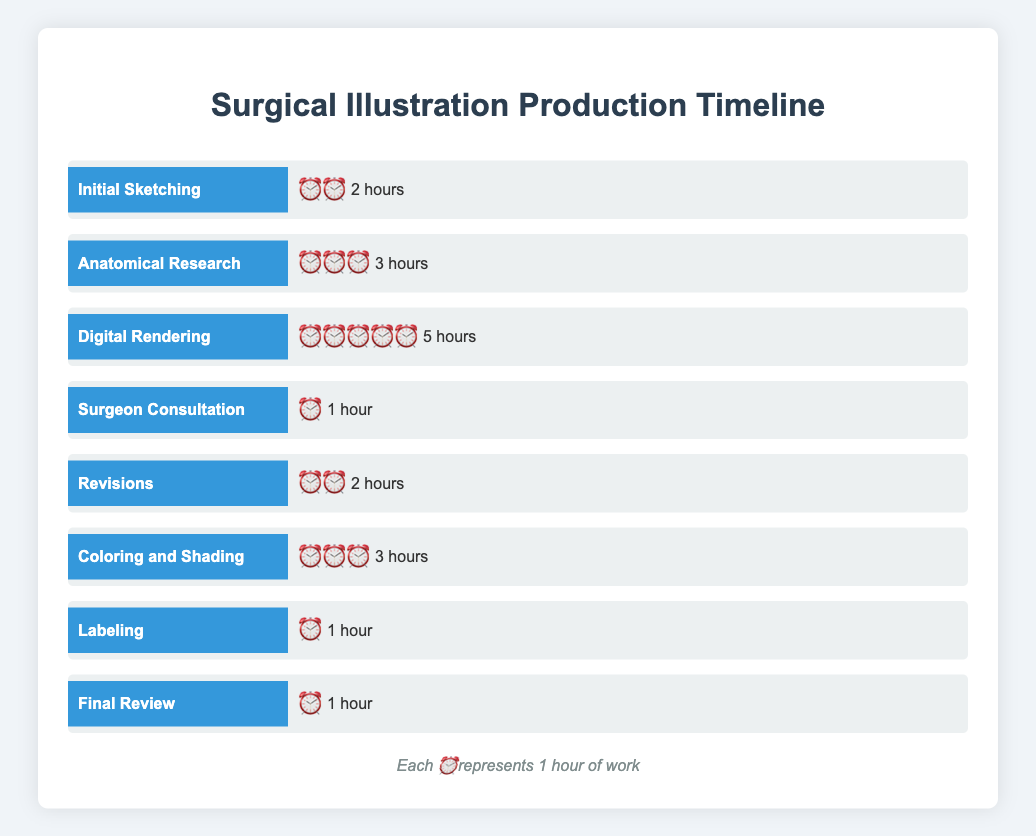What is the title of the figure? The title of the figure is usually displayed prominently at the top of the chart. Here, it states "Surgical Illustration Production Timeline."
Answer: Surgical Illustration Production Timeline How much time is spent on Initial Sketching? By looking at the "Initial Sketching" bar, you can see it is labeled with two clock emojis, indicating 2 hours.
Answer: 2 hours Which stage takes the longest time? Digital Rendering has the most clock emojis (5), meaning it takes the longest time.
Answer: Digital Rendering How much total time is spent on Surgeon Consultation and Labeling combined? Surgeon Consultation is 1 hour and Labeling is 1 hour, so together they sum up to 2 hours.
Answer: 2 hours What is the average time spent on Anatomical Research, Digital Rendering, and Coloring and Shading? Anatomical Research is 3 hours, Digital Rendering is 5 hours, and Coloring and Shading is 3 hours. The average is calculated as (3+5+3)/3, resulting in 3.67 hours.
Answer: 3.67 hours How does the time spent on Revisions compare to Initial Sketching? Both Revisions and Initial Sketching have 2 clock emojis, indicating they take the same amount of time.
Answer: Same If you add up all the time spent on all stages, what is the total? Total time is the sum of all stages: 2 + 3 + 5 + 1 + 2 + 3 + 1 + 1, which equals 18 hours.
Answer: 18 hours Is the time spent on Final Review more or less than Labeling? Both Final Review and Labeling have 1 clock emoji each, meaning the time spent is the same.
Answer: Same Which stages require exactly 3 hours? Anatomical Research and Coloring and Shading both have three clock emojis, indicating 3 hours each.
Answer: Anatomical Research, Coloring and Shading Compare the combined time of sketch-related stages (Initial Sketching and Digital Rendering) to the combined time of review stages (Revisions and Final Review). Which one takes more time? Summing sketch-related stages: 2 (Initial Sketching) + 5 (Digital Rendering) = 7 hours. Summing review stages: 2 (Revisions) + 1 (Final Review) = 3 hours. Hence, sketch-related stages take more time.
Answer: Sketch-related stages 